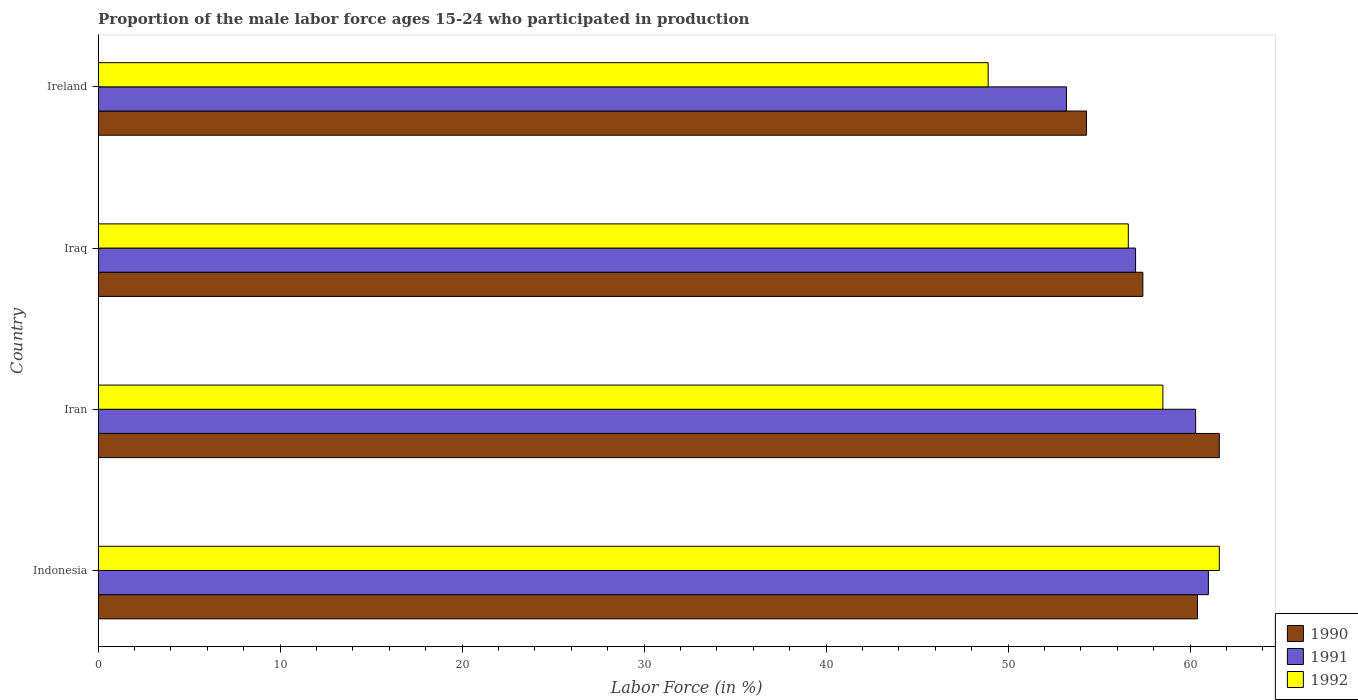How many different coloured bars are there?
Your answer should be very brief. 3. How many groups of bars are there?
Offer a terse response. 4. How many bars are there on the 3rd tick from the top?
Offer a terse response. 3. How many bars are there on the 1st tick from the bottom?
Keep it short and to the point. 3. In how many cases, is the number of bars for a given country not equal to the number of legend labels?
Provide a succinct answer. 0. What is the proportion of the male labor force who participated in production in 1992 in Ireland?
Your answer should be very brief. 48.9. Across all countries, what is the maximum proportion of the male labor force who participated in production in 1991?
Provide a succinct answer. 61. Across all countries, what is the minimum proportion of the male labor force who participated in production in 1992?
Offer a terse response. 48.9. In which country was the proportion of the male labor force who participated in production in 1990 maximum?
Your response must be concise. Iran. In which country was the proportion of the male labor force who participated in production in 1991 minimum?
Your response must be concise. Ireland. What is the total proportion of the male labor force who participated in production in 1990 in the graph?
Provide a succinct answer. 233.7. What is the difference between the proportion of the male labor force who participated in production in 1991 in Ireland and the proportion of the male labor force who participated in production in 1992 in Iran?
Provide a succinct answer. -5.3. What is the average proportion of the male labor force who participated in production in 1990 per country?
Provide a short and direct response. 58.43. What is the difference between the proportion of the male labor force who participated in production in 1991 and proportion of the male labor force who participated in production in 1990 in Ireland?
Make the answer very short. -1.1. What is the ratio of the proportion of the male labor force who participated in production in 1991 in Indonesia to that in Iran?
Your response must be concise. 1.01. Is the difference between the proportion of the male labor force who participated in production in 1991 in Iraq and Ireland greater than the difference between the proportion of the male labor force who participated in production in 1990 in Iraq and Ireland?
Your answer should be very brief. Yes. What is the difference between the highest and the second highest proportion of the male labor force who participated in production in 1991?
Make the answer very short. 0.7. What is the difference between the highest and the lowest proportion of the male labor force who participated in production in 1991?
Keep it short and to the point. 7.8. Is the sum of the proportion of the male labor force who participated in production in 1992 in Indonesia and Iran greater than the maximum proportion of the male labor force who participated in production in 1990 across all countries?
Your answer should be very brief. Yes. What does the 2nd bar from the top in Ireland represents?
Offer a terse response. 1991. Is it the case that in every country, the sum of the proportion of the male labor force who participated in production in 1992 and proportion of the male labor force who participated in production in 1990 is greater than the proportion of the male labor force who participated in production in 1991?
Offer a terse response. Yes. How many bars are there?
Ensure brevity in your answer.  12. Does the graph contain any zero values?
Your answer should be compact. No. Where does the legend appear in the graph?
Provide a short and direct response. Bottom right. What is the title of the graph?
Offer a very short reply. Proportion of the male labor force ages 15-24 who participated in production. Does "1968" appear as one of the legend labels in the graph?
Provide a succinct answer. No. What is the label or title of the X-axis?
Your answer should be compact. Labor Force (in %). What is the Labor Force (in %) in 1990 in Indonesia?
Your answer should be very brief. 60.4. What is the Labor Force (in %) of 1991 in Indonesia?
Your response must be concise. 61. What is the Labor Force (in %) of 1992 in Indonesia?
Your response must be concise. 61.6. What is the Labor Force (in %) in 1990 in Iran?
Provide a succinct answer. 61.6. What is the Labor Force (in %) of 1991 in Iran?
Provide a succinct answer. 60.3. What is the Labor Force (in %) in 1992 in Iran?
Offer a very short reply. 58.5. What is the Labor Force (in %) in 1990 in Iraq?
Provide a succinct answer. 57.4. What is the Labor Force (in %) in 1992 in Iraq?
Your response must be concise. 56.6. What is the Labor Force (in %) of 1990 in Ireland?
Provide a short and direct response. 54.3. What is the Labor Force (in %) in 1991 in Ireland?
Provide a succinct answer. 53.2. What is the Labor Force (in %) of 1992 in Ireland?
Make the answer very short. 48.9. Across all countries, what is the maximum Labor Force (in %) in 1990?
Your answer should be compact. 61.6. Across all countries, what is the maximum Labor Force (in %) of 1992?
Offer a terse response. 61.6. Across all countries, what is the minimum Labor Force (in %) in 1990?
Your answer should be very brief. 54.3. Across all countries, what is the minimum Labor Force (in %) in 1991?
Your answer should be very brief. 53.2. Across all countries, what is the minimum Labor Force (in %) of 1992?
Your answer should be very brief. 48.9. What is the total Labor Force (in %) of 1990 in the graph?
Make the answer very short. 233.7. What is the total Labor Force (in %) in 1991 in the graph?
Provide a succinct answer. 231.5. What is the total Labor Force (in %) in 1992 in the graph?
Keep it short and to the point. 225.6. What is the difference between the Labor Force (in %) of 1991 in Indonesia and that in Iran?
Ensure brevity in your answer.  0.7. What is the difference between the Labor Force (in %) of 1992 in Indonesia and that in Iran?
Provide a succinct answer. 3.1. What is the difference between the Labor Force (in %) of 1990 in Indonesia and that in Iraq?
Make the answer very short. 3. What is the difference between the Labor Force (in %) in 1990 in Indonesia and that in Ireland?
Make the answer very short. 6.1. What is the difference between the Labor Force (in %) of 1991 in Indonesia and that in Ireland?
Provide a succinct answer. 7.8. What is the difference between the Labor Force (in %) in 1990 in Iran and that in Iraq?
Your answer should be very brief. 4.2. What is the difference between the Labor Force (in %) of 1992 in Iran and that in Iraq?
Provide a succinct answer. 1.9. What is the difference between the Labor Force (in %) in 1991 in Iran and that in Ireland?
Provide a short and direct response. 7.1. What is the difference between the Labor Force (in %) of 1990 in Iraq and that in Ireland?
Ensure brevity in your answer.  3.1. What is the difference between the Labor Force (in %) of 1991 in Iraq and that in Ireland?
Your response must be concise. 3.8. What is the difference between the Labor Force (in %) of 1990 in Indonesia and the Labor Force (in %) of 1991 in Iran?
Your response must be concise. 0.1. What is the difference between the Labor Force (in %) of 1991 in Indonesia and the Labor Force (in %) of 1992 in Iran?
Offer a terse response. 2.5. What is the difference between the Labor Force (in %) of 1990 in Indonesia and the Labor Force (in %) of 1992 in Iraq?
Keep it short and to the point. 3.8. What is the difference between the Labor Force (in %) in 1990 in Indonesia and the Labor Force (in %) in 1991 in Ireland?
Your response must be concise. 7.2. What is the difference between the Labor Force (in %) in 1991 in Iran and the Labor Force (in %) in 1992 in Iraq?
Provide a succinct answer. 3.7. What is the difference between the Labor Force (in %) in 1990 in Iran and the Labor Force (in %) in 1991 in Ireland?
Offer a very short reply. 8.4. What is the difference between the Labor Force (in %) in 1990 in Iraq and the Labor Force (in %) in 1991 in Ireland?
Ensure brevity in your answer.  4.2. What is the difference between the Labor Force (in %) in 1990 in Iraq and the Labor Force (in %) in 1992 in Ireland?
Provide a succinct answer. 8.5. What is the difference between the Labor Force (in %) in 1991 in Iraq and the Labor Force (in %) in 1992 in Ireland?
Ensure brevity in your answer.  8.1. What is the average Labor Force (in %) of 1990 per country?
Your answer should be compact. 58.42. What is the average Labor Force (in %) in 1991 per country?
Keep it short and to the point. 57.88. What is the average Labor Force (in %) in 1992 per country?
Give a very brief answer. 56.4. What is the difference between the Labor Force (in %) in 1990 and Labor Force (in %) in 1991 in Indonesia?
Your answer should be very brief. -0.6. What is the difference between the Labor Force (in %) of 1990 and Labor Force (in %) of 1992 in Indonesia?
Keep it short and to the point. -1.2. What is the difference between the Labor Force (in %) of 1990 and Labor Force (in %) of 1991 in Iran?
Your response must be concise. 1.3. What is the difference between the Labor Force (in %) of 1991 and Labor Force (in %) of 1992 in Iran?
Keep it short and to the point. 1.8. What is the difference between the Labor Force (in %) of 1990 and Labor Force (in %) of 1991 in Iraq?
Make the answer very short. 0.4. What is the difference between the Labor Force (in %) of 1990 and Labor Force (in %) of 1992 in Iraq?
Your response must be concise. 0.8. What is the difference between the Labor Force (in %) in 1991 and Labor Force (in %) in 1992 in Iraq?
Your response must be concise. 0.4. What is the difference between the Labor Force (in %) of 1990 and Labor Force (in %) of 1991 in Ireland?
Your answer should be very brief. 1.1. What is the difference between the Labor Force (in %) in 1990 and Labor Force (in %) in 1992 in Ireland?
Ensure brevity in your answer.  5.4. What is the difference between the Labor Force (in %) in 1991 and Labor Force (in %) in 1992 in Ireland?
Give a very brief answer. 4.3. What is the ratio of the Labor Force (in %) of 1990 in Indonesia to that in Iran?
Offer a terse response. 0.98. What is the ratio of the Labor Force (in %) of 1991 in Indonesia to that in Iran?
Provide a short and direct response. 1.01. What is the ratio of the Labor Force (in %) in 1992 in Indonesia to that in Iran?
Give a very brief answer. 1.05. What is the ratio of the Labor Force (in %) in 1990 in Indonesia to that in Iraq?
Provide a succinct answer. 1.05. What is the ratio of the Labor Force (in %) of 1991 in Indonesia to that in Iraq?
Give a very brief answer. 1.07. What is the ratio of the Labor Force (in %) in 1992 in Indonesia to that in Iraq?
Your answer should be compact. 1.09. What is the ratio of the Labor Force (in %) of 1990 in Indonesia to that in Ireland?
Provide a short and direct response. 1.11. What is the ratio of the Labor Force (in %) in 1991 in Indonesia to that in Ireland?
Offer a very short reply. 1.15. What is the ratio of the Labor Force (in %) in 1992 in Indonesia to that in Ireland?
Offer a terse response. 1.26. What is the ratio of the Labor Force (in %) in 1990 in Iran to that in Iraq?
Ensure brevity in your answer.  1.07. What is the ratio of the Labor Force (in %) in 1991 in Iran to that in Iraq?
Give a very brief answer. 1.06. What is the ratio of the Labor Force (in %) in 1992 in Iran to that in Iraq?
Ensure brevity in your answer.  1.03. What is the ratio of the Labor Force (in %) in 1990 in Iran to that in Ireland?
Keep it short and to the point. 1.13. What is the ratio of the Labor Force (in %) in 1991 in Iran to that in Ireland?
Your response must be concise. 1.13. What is the ratio of the Labor Force (in %) in 1992 in Iran to that in Ireland?
Provide a short and direct response. 1.2. What is the ratio of the Labor Force (in %) of 1990 in Iraq to that in Ireland?
Offer a terse response. 1.06. What is the ratio of the Labor Force (in %) of 1991 in Iraq to that in Ireland?
Ensure brevity in your answer.  1.07. What is the ratio of the Labor Force (in %) of 1992 in Iraq to that in Ireland?
Your answer should be very brief. 1.16. What is the difference between the highest and the second highest Labor Force (in %) of 1990?
Provide a succinct answer. 1.2. What is the difference between the highest and the second highest Labor Force (in %) of 1992?
Offer a very short reply. 3.1. What is the difference between the highest and the lowest Labor Force (in %) of 1991?
Keep it short and to the point. 7.8. What is the difference between the highest and the lowest Labor Force (in %) of 1992?
Offer a terse response. 12.7. 